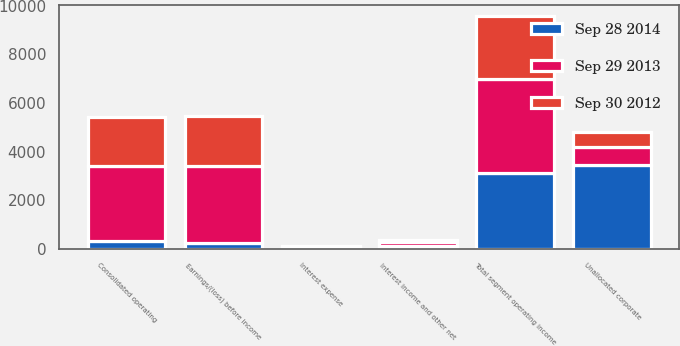Convert chart to OTSL. <chart><loc_0><loc_0><loc_500><loc_500><stacked_bar_chart><ecel><fcel>Total segment operating income<fcel>Unallocated corporate<fcel>Consolidated operating<fcel>Interest income and other net<fcel>Interest expense<fcel>Earnings/(loss) before income<nl><fcel>Sep 29 2013<fcel>3831.1<fcel>750<fcel>3081.1<fcel>142.7<fcel>64.1<fcel>3159.7<nl><fcel>Sep 28 2014<fcel>3131.6<fcel>3457<fcel>325.4<fcel>123.6<fcel>28.1<fcel>229.9<nl><fcel>Sep 30 2012<fcel>2592.8<fcel>595.4<fcel>1997.4<fcel>94.4<fcel>32.7<fcel>2059.1<nl></chart> 